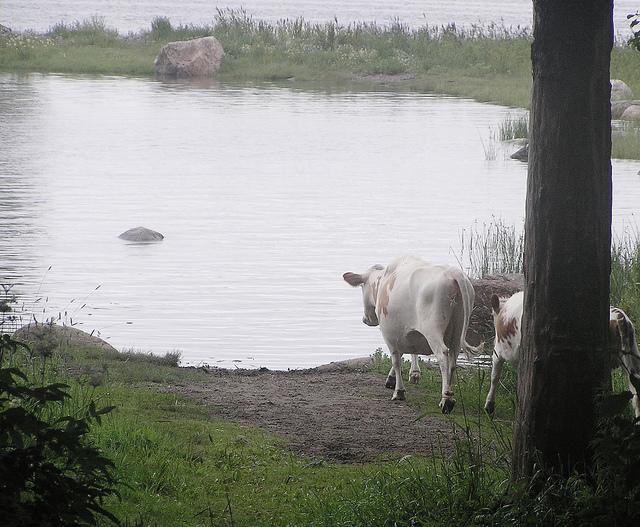What is the smell?
Answer briefly. Cows. How many trees can you see?
Be succinct. 1. Will this be a good place to surf?
Concise answer only. No. Is there a fence?
Concise answer only. No. Is this a big or small body of water?
Concise answer only. Small. 